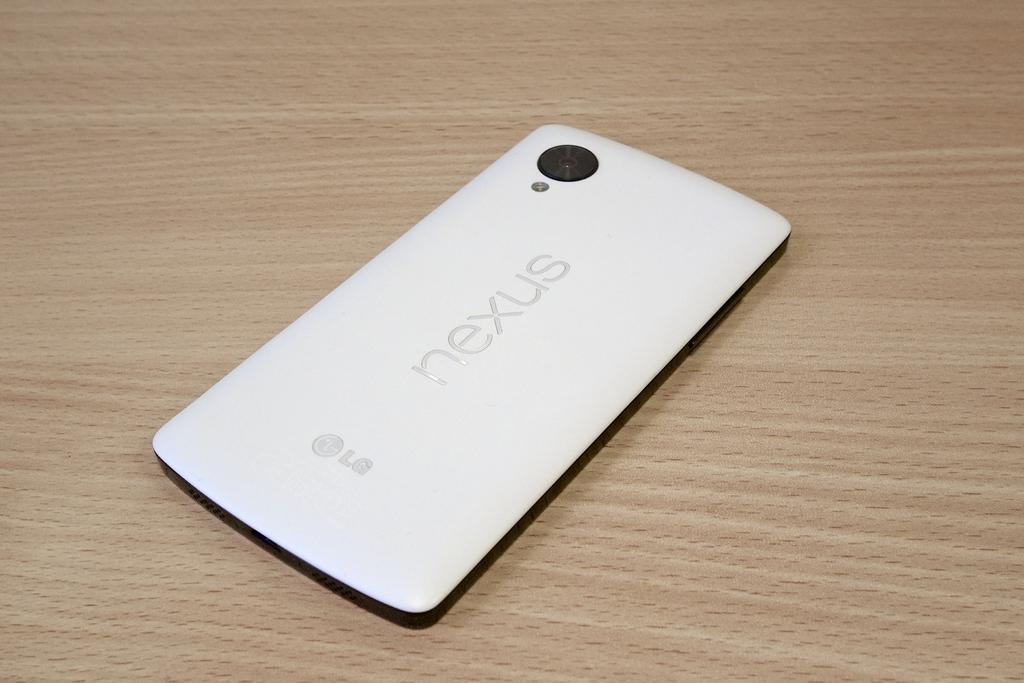<image>
Relay a brief, clear account of the picture shown. A LG brand Nexus phone is on the table. 